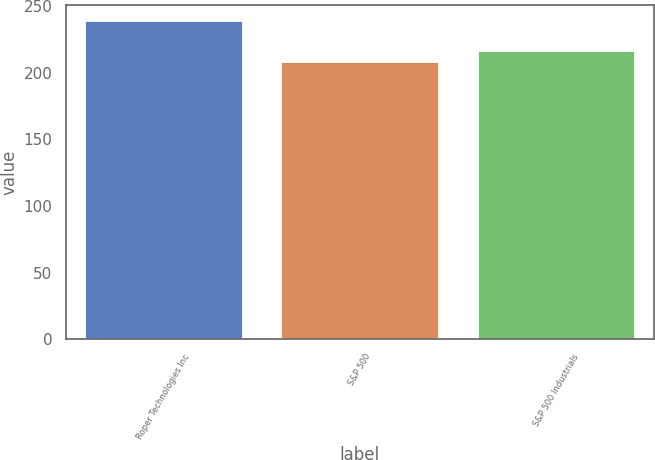Convert chart. <chart><loc_0><loc_0><loc_500><loc_500><bar_chart><fcel>Roper Technologies Inc<fcel>S&P 500<fcel>S&P 500 Industrials<nl><fcel>239.15<fcel>208.14<fcel>216.64<nl></chart> 